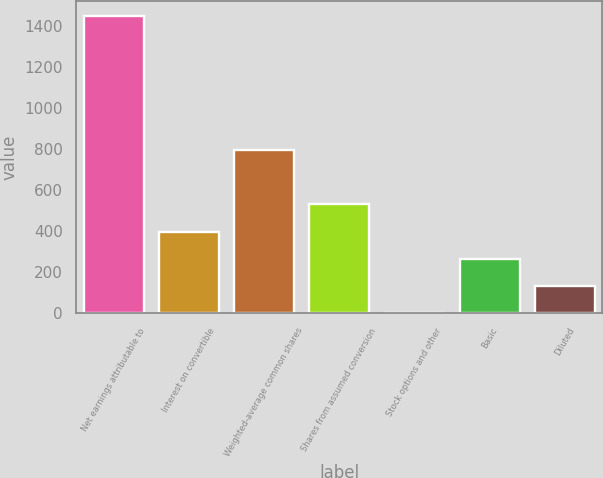<chart> <loc_0><loc_0><loc_500><loc_500><bar_chart><fcel>Net earnings attributable to<fcel>Interest on convertible<fcel>Weighted-average common shares<fcel>Shares from assumed conversion<fcel>Stock options and other<fcel>Basic<fcel>Diluted<nl><fcel>1449.11<fcel>398.23<fcel>794.56<fcel>530.34<fcel>1.9<fcel>266.12<fcel>134.01<nl></chart> 